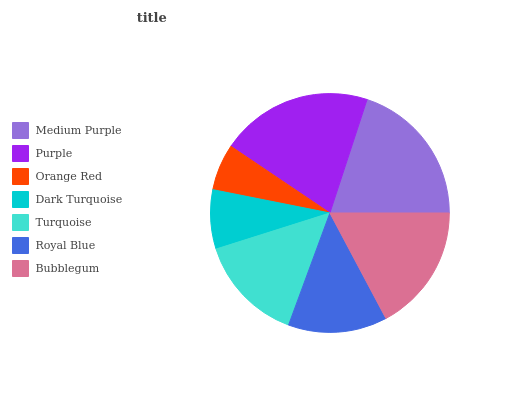Is Orange Red the minimum?
Answer yes or no. Yes. Is Purple the maximum?
Answer yes or no. Yes. Is Purple the minimum?
Answer yes or no. No. Is Orange Red the maximum?
Answer yes or no. No. Is Purple greater than Orange Red?
Answer yes or no. Yes. Is Orange Red less than Purple?
Answer yes or no. Yes. Is Orange Red greater than Purple?
Answer yes or no. No. Is Purple less than Orange Red?
Answer yes or no. No. Is Turquoise the high median?
Answer yes or no. Yes. Is Turquoise the low median?
Answer yes or no. Yes. Is Orange Red the high median?
Answer yes or no. No. Is Bubblegum the low median?
Answer yes or no. No. 